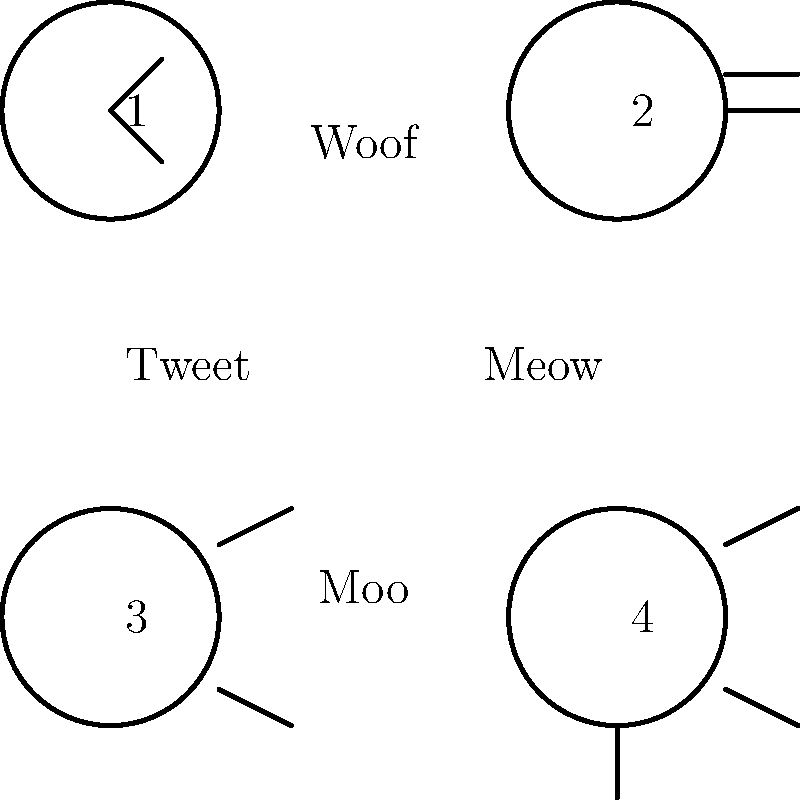Match the animal sounds to their correct images by drawing lines between them. Which number corresponds to the animal that says "Moo"? Let's go through this step-by-step:

1. We have four animal images, numbered 1 to 4.
2. We also have four animal sounds: Tweet, Woof, Meow, and Moo.
3. Let's match each sound to its corresponding animal:
   - Tweet is the sound a bird makes, which is image 1.
   - Woof is the sound a dog makes, which is image 2.
   - Meow is the sound a cat makes, which is image 3.
   - Moo is the sound a cow makes, which is image 4.
4. The question asks specifically about the animal that says "Moo".
5. We identified that "Moo" corresponds to the cow.
6. The cow is represented by image number 4.

Therefore, the number that corresponds to the animal that says "Moo" is 4.
Answer: 4 